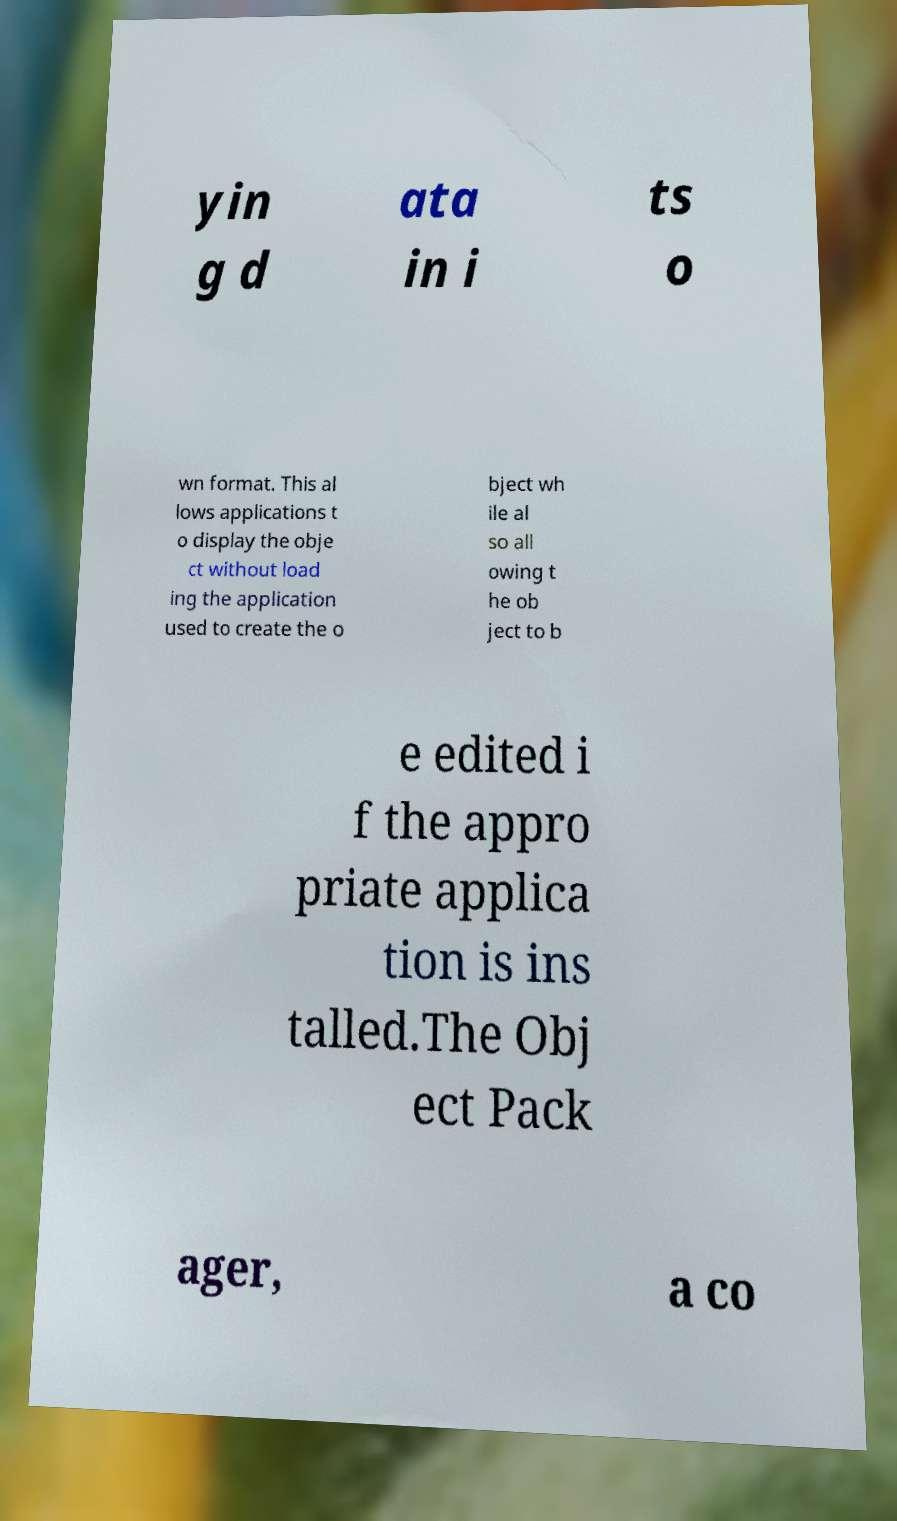Please identify and transcribe the text found in this image. yin g d ata in i ts o wn format. This al lows applications t o display the obje ct without load ing the application used to create the o bject wh ile al so all owing t he ob ject to b e edited i f the appro priate applica tion is ins talled.The Obj ect Pack ager, a co 